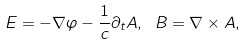Convert formula to latex. <formula><loc_0><loc_0><loc_500><loc_500>E = - \nabla \varphi - \frac { 1 } { c } \partial _ { t } A , \ B = \nabla \times A ,</formula> 